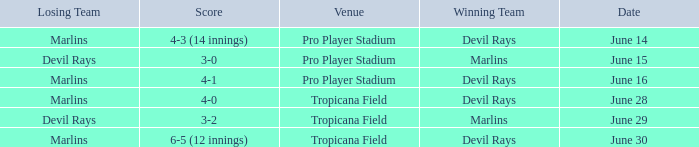What was the score of the game at pro player stadium on june 14? 4-3 (14 innings). 